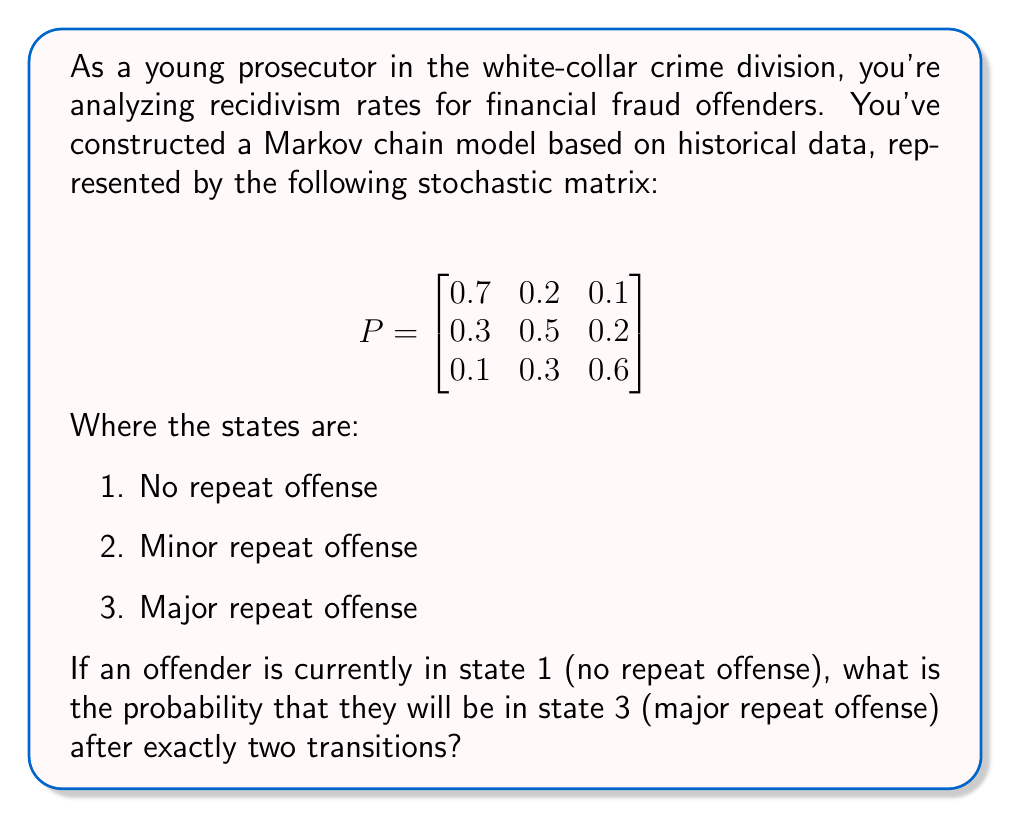What is the answer to this math problem? To solve this problem, we need to use the properties of Markov chains and stochastic matrices. The given matrix $P$ represents the transition probabilities between states in a single step.

1) We need to find the probability of moving from state 1 to state 3 in exactly two steps.

2) This can be calculated by multiplying the matrix $P$ by itself (i.e., $P^2$), which gives us the two-step transition probabilities.

3) Let's calculate $P^2$:

   $$P^2 = P \times P = \begin{bmatrix}
   0.7 & 0.2 & 0.1 \\
   0.3 & 0.5 & 0.2 \\
   0.1 & 0.3 & 0.6
   \end{bmatrix} \times \begin{bmatrix}
   0.7 & 0.2 & 0.1 \\
   0.3 & 0.5 & 0.2 \\
   0.1 & 0.3 & 0.6
   \end{bmatrix}$$

4) Performing the matrix multiplication:

   $$P^2 = \begin{bmatrix}
   0.56 & 0.27 & 0.17 \\
   0.43 & 0.37 & 0.20 \\
   0.22 & 0.36 & 0.42
   \end{bmatrix}$$

5) The probability we're looking for is the element in the first row (since we start in state 1) and third column (since we want to end in state 3) of $P^2$.

6) This value is 0.17 or 17%.

Therefore, the probability that an offender currently in state 1 (no repeat offense) will be in state 3 (major repeat offense) after exactly two transitions is 0.17 or 17%.
Answer: 0.17 